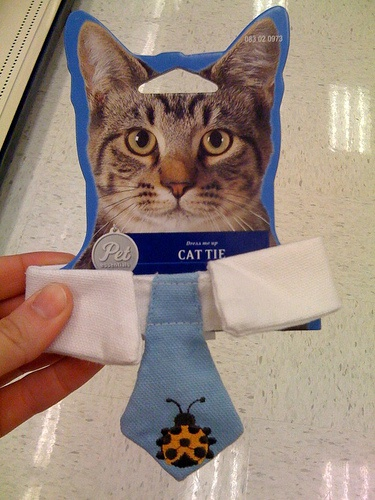Describe the objects in this image and their specific colors. I can see cat in olive, gray, maroon, brown, and black tones, tie in olive, gray, and black tones, and people in olive, maroon, and brown tones in this image. 